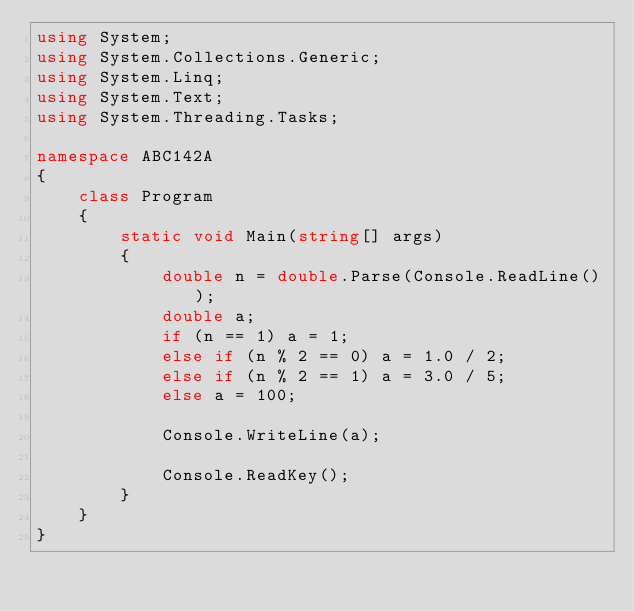<code> <loc_0><loc_0><loc_500><loc_500><_C#_>using System;
using System.Collections.Generic;
using System.Linq;
using System.Text;
using System.Threading.Tasks;

namespace ABC142A
{
    class Program
    {
        static void Main(string[] args)
        {
            double n = double.Parse(Console.ReadLine());
            double a;
            if (n == 1) a = 1;
            else if (n % 2 == 0) a = 1.0 / 2;
            else if (n % 2 == 1) a = 3.0 / 5;
            else a = 100;

            Console.WriteLine(a);

            Console.ReadKey();
        }
    }
}
</code> 